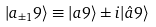<formula> <loc_0><loc_0><loc_500><loc_500>| a _ { \pm 1 } 9 \rangle \equiv | a 9 \rangle \pm i | \hat { a } 9 \rangle</formula> 